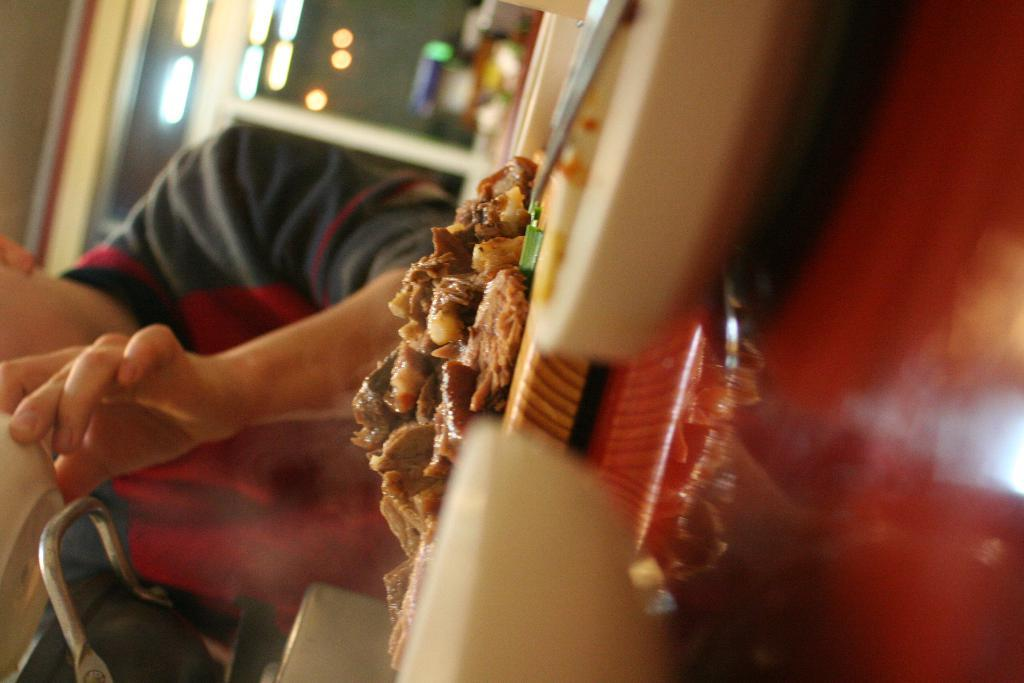Who is present in the image? There is a man in the image. What is the man doing in the image? The man is seated on a chair and holding a bowl. What is on the table in front of the man? There is food on the table in front of the man. What can be seen in the background of the image? There are lights visible in the background of the image. What type of sand can be seen on the table in the image? There is no sand present on the table in the image. What error is the man correcting in the image? There is no indication of an error or correction in the image. 